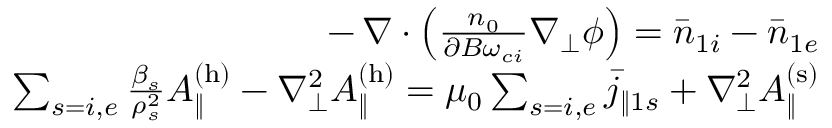Convert formula to latex. <formula><loc_0><loc_0><loc_500><loc_500>\begin{array} { r l r } & { \, - \, \nabla \cdot \left ( \frac { n _ { 0 } } { \partial B \omega _ { c i } } \nabla _ { \perp } \phi \right ) = \bar { n } _ { 1 i } - \bar { n } _ { 1 e } } \\ & { \sum _ { s = i , e } \frac { \beta _ { s } } { \rho _ { s } ^ { 2 } } A _ { \| } ^ { ( h ) } - \nabla _ { \perp } ^ { 2 } A _ { \| } ^ { ( h ) } = \mu _ { 0 } \sum _ { s = i , e } \bar { j } _ { \| 1 s } + \nabla _ { \perp } ^ { 2 } A _ { \| } ^ { ( s ) } } \end{array}</formula> 